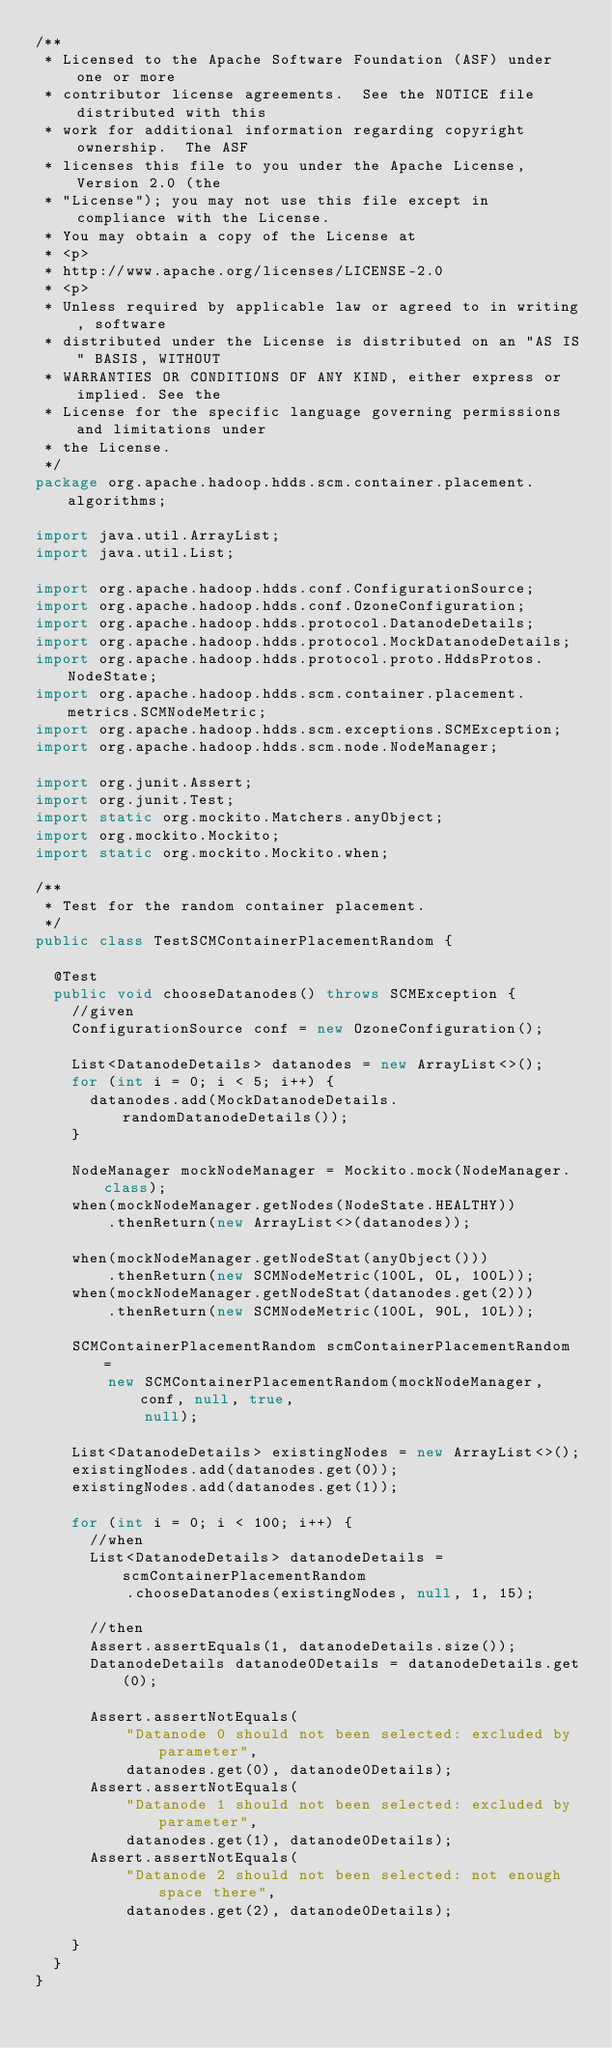<code> <loc_0><loc_0><loc_500><loc_500><_Java_>/**
 * Licensed to the Apache Software Foundation (ASF) under one or more
 * contributor license agreements.  See the NOTICE file distributed with this
 * work for additional information regarding copyright ownership.  The ASF
 * licenses this file to you under the Apache License, Version 2.0 (the
 * "License"); you may not use this file except in compliance with the License.
 * You may obtain a copy of the License at
 * <p>
 * http://www.apache.org/licenses/LICENSE-2.0
 * <p>
 * Unless required by applicable law or agreed to in writing, software
 * distributed under the License is distributed on an "AS IS" BASIS, WITHOUT
 * WARRANTIES OR CONDITIONS OF ANY KIND, either express or implied. See the
 * License for the specific language governing permissions and limitations under
 * the License.
 */
package org.apache.hadoop.hdds.scm.container.placement.algorithms;

import java.util.ArrayList;
import java.util.List;

import org.apache.hadoop.hdds.conf.ConfigurationSource;
import org.apache.hadoop.hdds.conf.OzoneConfiguration;
import org.apache.hadoop.hdds.protocol.DatanodeDetails;
import org.apache.hadoop.hdds.protocol.MockDatanodeDetails;
import org.apache.hadoop.hdds.protocol.proto.HddsProtos.NodeState;
import org.apache.hadoop.hdds.scm.container.placement.metrics.SCMNodeMetric;
import org.apache.hadoop.hdds.scm.exceptions.SCMException;
import org.apache.hadoop.hdds.scm.node.NodeManager;

import org.junit.Assert;
import org.junit.Test;
import static org.mockito.Matchers.anyObject;
import org.mockito.Mockito;
import static org.mockito.Mockito.when;

/**
 * Test for the random container placement.
 */
public class TestSCMContainerPlacementRandom {

  @Test
  public void chooseDatanodes() throws SCMException {
    //given
    ConfigurationSource conf = new OzoneConfiguration();

    List<DatanodeDetails> datanodes = new ArrayList<>();
    for (int i = 0; i < 5; i++) {
      datanodes.add(MockDatanodeDetails.randomDatanodeDetails());
    }

    NodeManager mockNodeManager = Mockito.mock(NodeManager.class);
    when(mockNodeManager.getNodes(NodeState.HEALTHY))
        .thenReturn(new ArrayList<>(datanodes));

    when(mockNodeManager.getNodeStat(anyObject()))
        .thenReturn(new SCMNodeMetric(100L, 0L, 100L));
    when(mockNodeManager.getNodeStat(datanodes.get(2)))
        .thenReturn(new SCMNodeMetric(100L, 90L, 10L));

    SCMContainerPlacementRandom scmContainerPlacementRandom =
        new SCMContainerPlacementRandom(mockNodeManager, conf, null, true,
            null);

    List<DatanodeDetails> existingNodes = new ArrayList<>();
    existingNodes.add(datanodes.get(0));
    existingNodes.add(datanodes.get(1));

    for (int i = 0; i < 100; i++) {
      //when
      List<DatanodeDetails> datanodeDetails = scmContainerPlacementRandom
          .chooseDatanodes(existingNodes, null, 1, 15);

      //then
      Assert.assertEquals(1, datanodeDetails.size());
      DatanodeDetails datanode0Details = datanodeDetails.get(0);

      Assert.assertNotEquals(
          "Datanode 0 should not been selected: excluded by parameter",
          datanodes.get(0), datanode0Details);
      Assert.assertNotEquals(
          "Datanode 1 should not been selected: excluded by parameter",
          datanodes.get(1), datanode0Details);
      Assert.assertNotEquals(
          "Datanode 2 should not been selected: not enough space there",
          datanodes.get(2), datanode0Details);

    }
  }
}</code> 